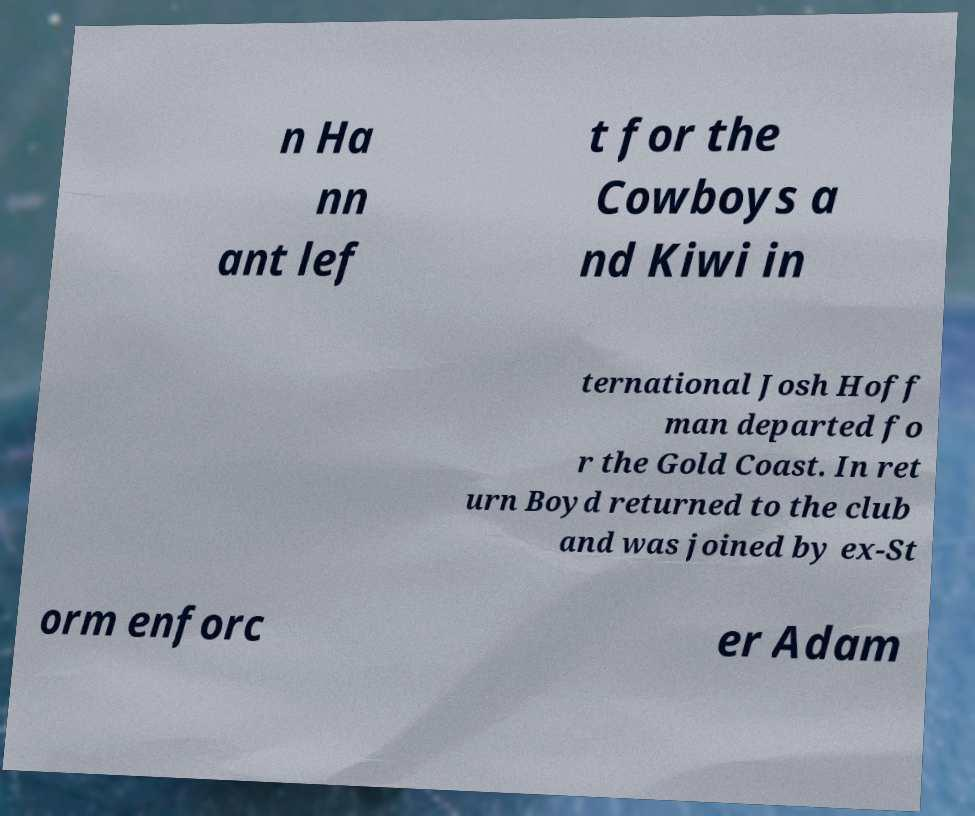Can you accurately transcribe the text from the provided image for me? n Ha nn ant lef t for the Cowboys a nd Kiwi in ternational Josh Hoff man departed fo r the Gold Coast. In ret urn Boyd returned to the club and was joined by ex-St orm enforc er Adam 